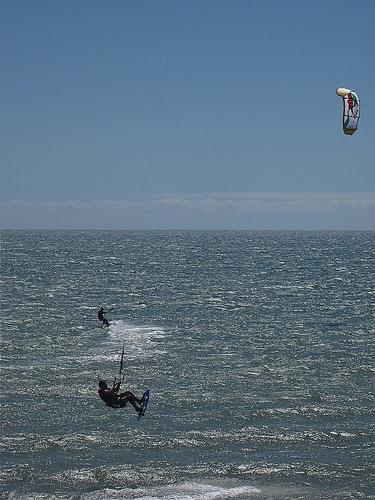Estimate the number of water sports-related objects in the image. At least 7 objects are related to water sports (wind surfing, kite boarding, surfing board, kite, etc.). Quantify the instances of men engaging in water-related sports. Two men are engaging in water-related sports. Analyze the interaction between the man and the object in the sky. The man is kite surfing, using the kite in the air to propel himself on the water. Enumerate the different elements related to the water in the image. Vast blue ocean, calm sea waters, part of the blue water, a blue water surface, waves on top of water, waves caused by the wind, white water splashing, sun reflecting on water. Based on the image, describe the weather and environment. The weather appears sunny and clear, with blue skies and white clouds in the sky, and calm sea waters. Identify the primary activity taking place in the image. A man is kite surfing in the ocean. What elements contribute to the sentiment of the image and describe the sentiment. The vast blue ocean, calm sea waters, blue skies, and white clouds contribute to a peaceful and serene sentiment. Evaluate the quality of the image by identifying any noticeable elements (such as noise, blur, or sharpness). It is not possible to evaluate the quality of the image with the provided information. 